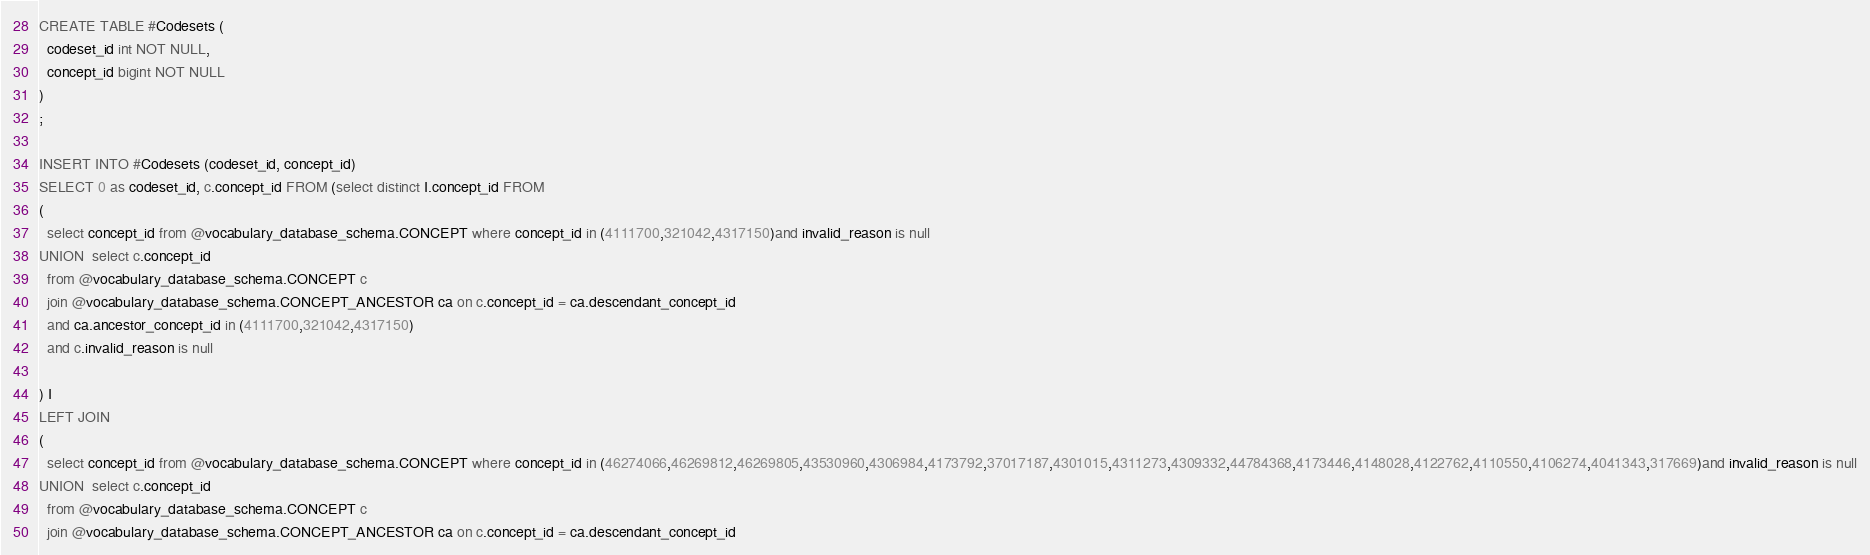<code> <loc_0><loc_0><loc_500><loc_500><_SQL_>CREATE TABLE #Codesets (
  codeset_id int NOT NULL,
  concept_id bigint NOT NULL
)
;

INSERT INTO #Codesets (codeset_id, concept_id)
SELECT 0 as codeset_id, c.concept_id FROM (select distinct I.concept_id FROM
( 
  select concept_id from @vocabulary_database_schema.CONCEPT where concept_id in (4111700,321042,4317150)and invalid_reason is null
UNION  select c.concept_id
  from @vocabulary_database_schema.CONCEPT c
  join @vocabulary_database_schema.CONCEPT_ANCESTOR ca on c.concept_id = ca.descendant_concept_id
  and ca.ancestor_concept_id in (4111700,321042,4317150)
  and c.invalid_reason is null

) I
LEFT JOIN
(
  select concept_id from @vocabulary_database_schema.CONCEPT where concept_id in (46274066,46269812,46269805,43530960,4306984,4173792,37017187,4301015,4311273,4309332,44784368,4173446,4148028,4122762,4110550,4106274,4041343,317669)and invalid_reason is null
UNION  select c.concept_id
  from @vocabulary_database_schema.CONCEPT c
  join @vocabulary_database_schema.CONCEPT_ANCESTOR ca on c.concept_id = ca.descendant_concept_id</code> 